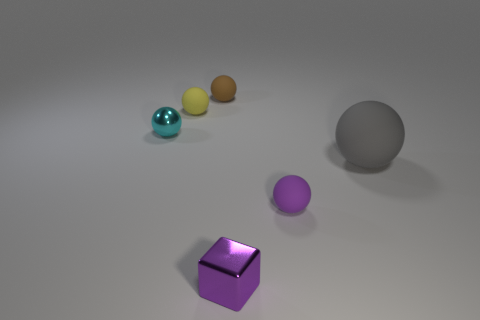What number of small brown objects are there?
Provide a short and direct response. 1. Is there any other thing that is the same size as the gray ball?
Your answer should be compact. No. Are the cyan ball and the small block made of the same material?
Your response must be concise. Yes. There is a shiny object behind the purple sphere; does it have the same size as the object to the right of the small purple rubber ball?
Make the answer very short. No. Is the number of tiny purple shiny objects less than the number of balls?
Provide a short and direct response. Yes. How many rubber objects are either tiny brown cubes or purple cubes?
Keep it short and to the point. 0. There is a metal object to the right of the tiny cyan ball; is there a brown rubber object that is in front of it?
Give a very brief answer. No. Are the sphere that is in front of the large matte sphere and the brown object made of the same material?
Offer a very short reply. Yes. What number of other objects are the same color as the big rubber object?
Your response must be concise. 0. How big is the purple thing in front of the small rubber ball to the right of the tiny purple shiny object?
Offer a terse response. Small. 